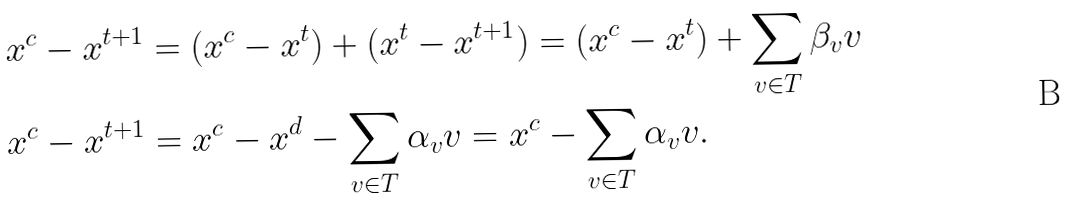Convert formula to latex. <formula><loc_0><loc_0><loc_500><loc_500>x ^ { c } - x ^ { t + 1 } & = ( x ^ { c } - x ^ { t } ) + ( x ^ { t } - x ^ { t + 1 } ) = ( x ^ { c } - x ^ { t } ) + \sum _ { v \in T } \beta _ { v } v \\ x ^ { c } - x ^ { t + 1 } & = x ^ { c } - x ^ { d } - \sum _ { v \in T } \alpha _ { v } v = x ^ { c } - \sum _ { v \in T } \alpha _ { v } v .</formula> 